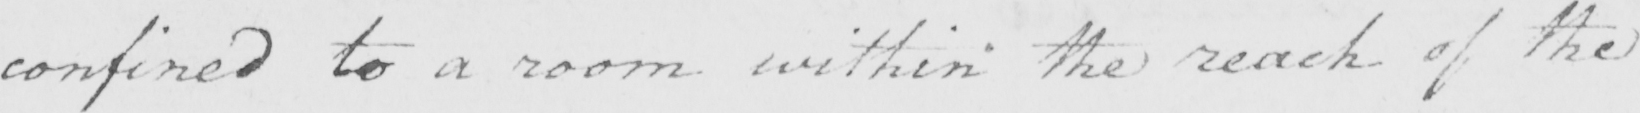Can you read and transcribe this handwriting? confined to a room within the reach of the 